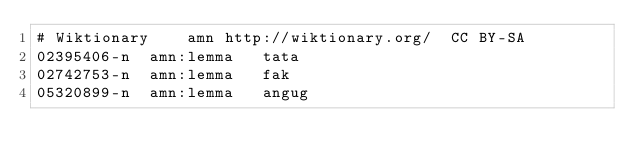<code> <loc_0><loc_0><loc_500><loc_500><_SQL_># Wiktionary	amn	http://wiktionary.org/	CC BY-SA
02395406-n	amn:lemma	tata
02742753-n	amn:lemma	fak
05320899-n	amn:lemma	angug
</code> 